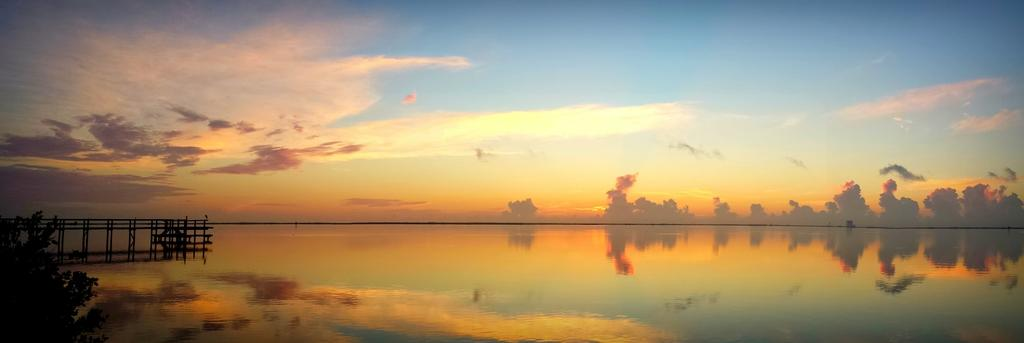What is the primary element visible in the image? There is water in the image. What type of structure can be seen in the image? There is a fence in the image. What type of vegetation is present in the image? There are plants and trees in the image. What part of the natural environment is visible in the image? The sky is visible in the image, and clouds are present. What type of sheet is being used for driving in the image? There is no sheet or driving activity present in the image. 